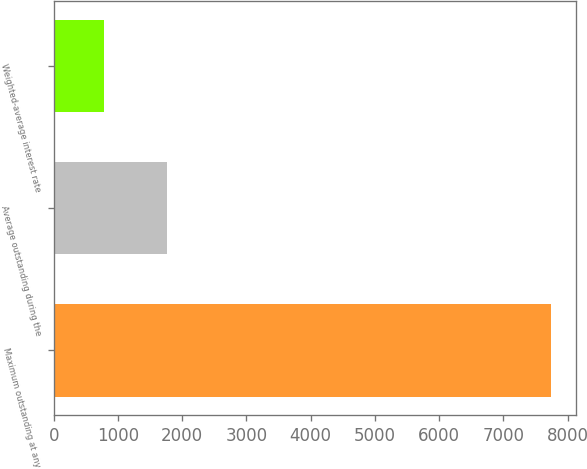Convert chart to OTSL. <chart><loc_0><loc_0><loc_500><loc_500><bar_chart><fcel>Maximum outstanding at any<fcel>Average outstanding during the<fcel>Weighted-average interest rate<nl><fcel>7748<fcel>1759<fcel>774.81<nl></chart> 